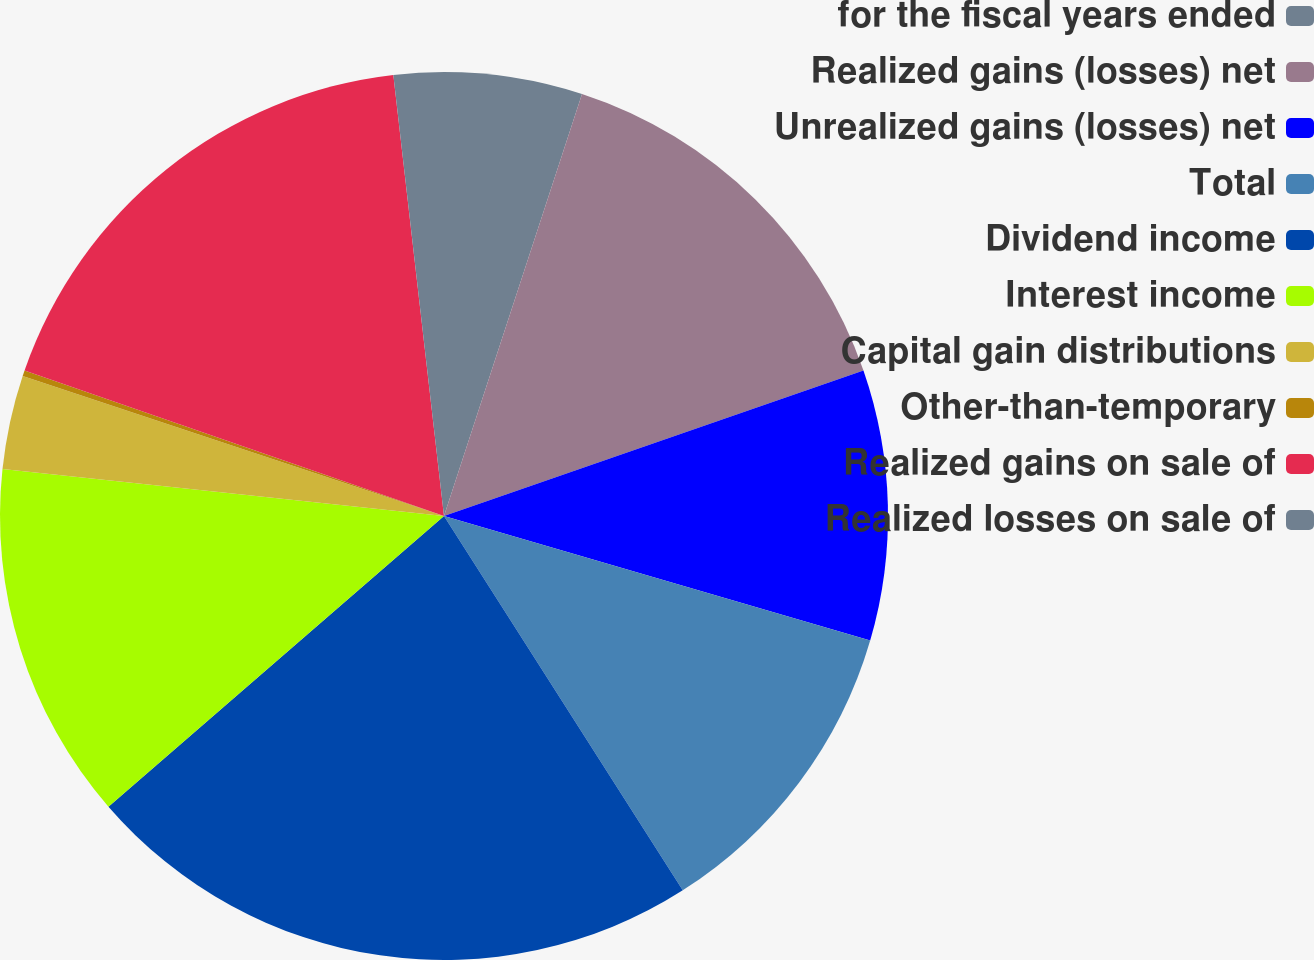<chart> <loc_0><loc_0><loc_500><loc_500><pie_chart><fcel>for the fiscal years ended<fcel>Realized gains (losses) net<fcel>Unrealized gains (losses) net<fcel>Total<fcel>Dividend income<fcel>Interest income<fcel>Capital gain distributions<fcel>Other-than-temporary<fcel>Realized gains on sale of<fcel>Realized losses on sale of<nl><fcel>5.03%<fcel>14.65%<fcel>9.84%<fcel>11.44%<fcel>22.67%<fcel>13.05%<fcel>3.42%<fcel>0.21%<fcel>17.86%<fcel>1.82%<nl></chart> 